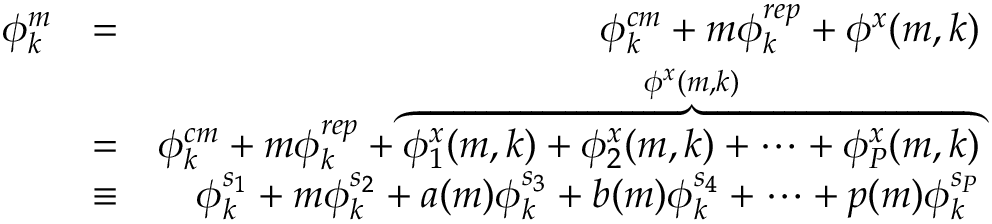Convert formula to latex. <formula><loc_0><loc_0><loc_500><loc_500>\begin{array} { r l r } { \phi _ { k } ^ { m } } & { = } & { \phi _ { k } ^ { c m } + m \phi _ { k } ^ { r e p } + \phi ^ { x } ( m , k ) } \\ & { = } & { \phi _ { k } ^ { c m } + m \phi _ { k } ^ { r e p } + \overbrace { \phi _ { 1 } ^ { x } ( m , k ) + \phi _ { 2 } ^ { x } ( m , k ) + \cdots + \phi _ { P } ^ { x } ( m , k ) } ^ { \phi ^ { x } ( m , k ) } } \\ & { \equiv } & { \phi _ { k } ^ { s _ { 1 } } + m \phi _ { k } ^ { s _ { 2 } } + a ( m ) \phi _ { k } ^ { s _ { 3 } } + b ( m ) \phi _ { k } ^ { s _ { 4 } } + \cdots + p ( m ) \phi _ { k } ^ { s _ { P } } } \end{array}</formula> 